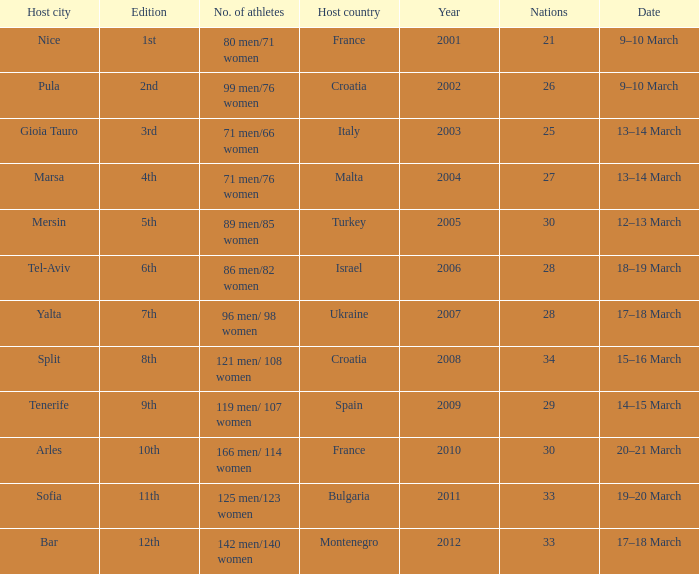Who was the host country when Bar was the host city? Montenegro. 